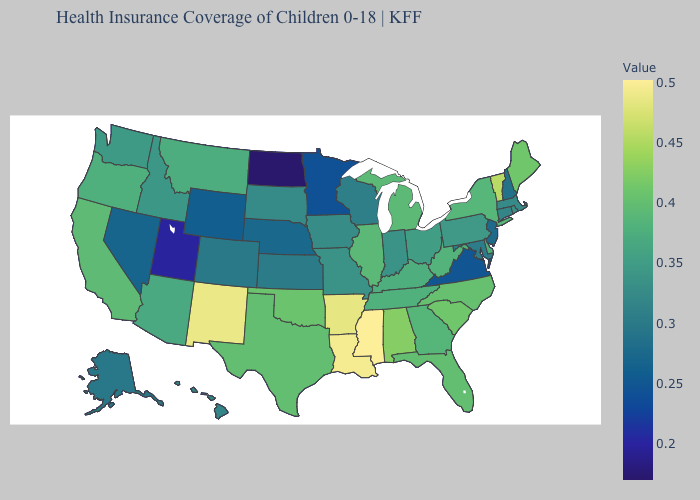Which states have the highest value in the USA?
Keep it brief. Mississippi. Does Alaska have a higher value than Utah?
Write a very short answer. Yes. Does Mississippi have the highest value in the USA?
Keep it brief. Yes. Among the states that border South Dakota , which have the highest value?
Keep it brief. Montana. Which states have the lowest value in the USA?
Be succinct. North Dakota. 